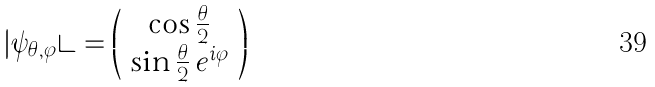Convert formula to latex. <formula><loc_0><loc_0><loc_500><loc_500>| \psi _ { \theta , \varphi } \rangle = \left ( \begin{array} { c } \cos { \frac { \theta } { 2 } } \\ \sin { \frac { \theta } { 2 } } \, e ^ { i \varphi } \end{array} \right )</formula> 